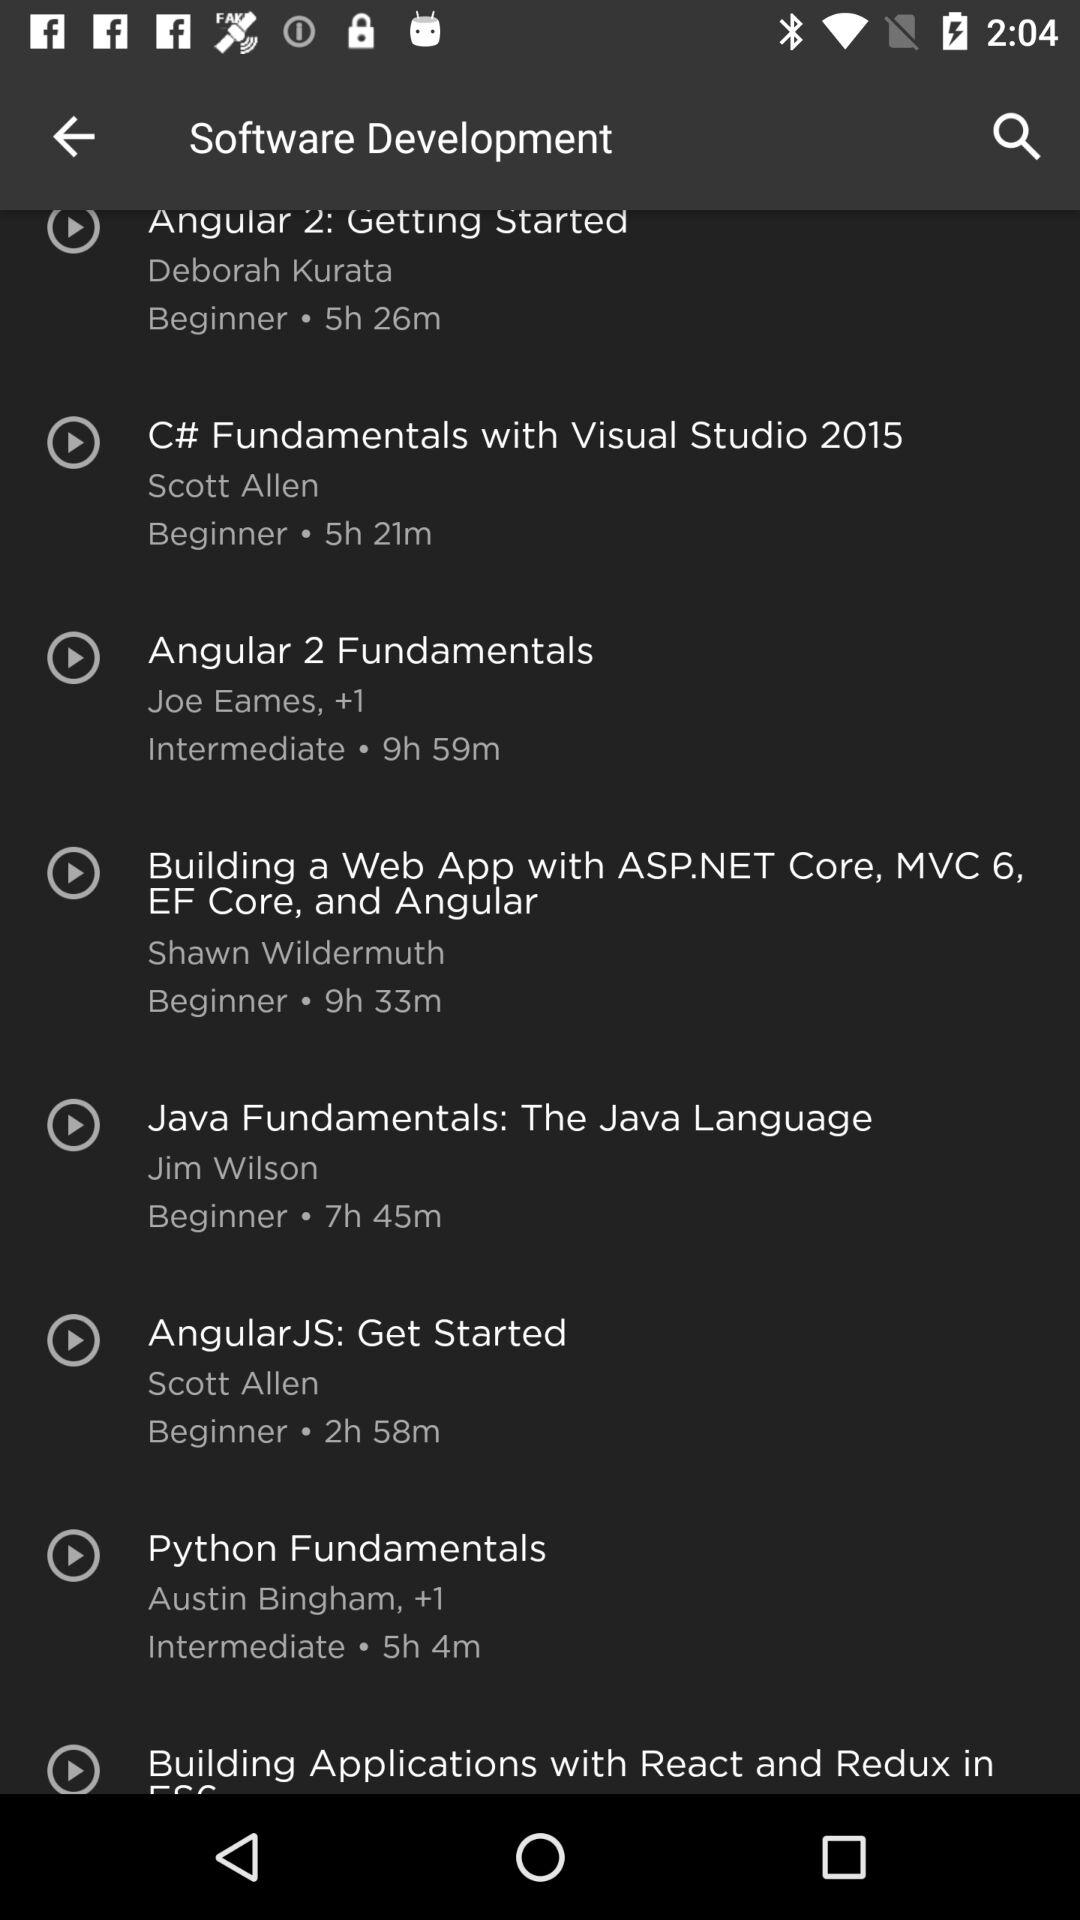What is the duration of the "Java Fundamentals" course? The duration of the "Java Fundamentals" course is 7 hours 45 minutes. 